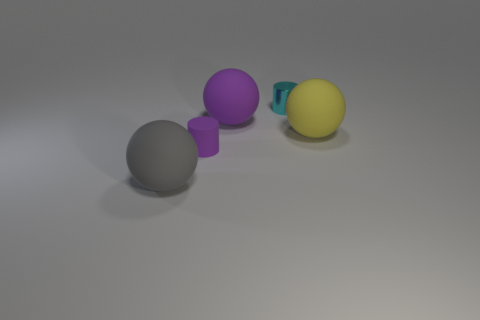The purple thing in front of the yellow matte object has what shape?
Provide a succinct answer. Cylinder. Are there fewer big gray objects than large blue metal cylinders?
Your response must be concise. No. There is a cylinder behind the yellow thing that is in front of the metal cylinder; are there any gray balls behind it?
Offer a very short reply. No. What number of matte things are objects or large balls?
Give a very brief answer. 4. There is a large yellow object; how many gray balls are behind it?
Your answer should be compact. 0. What number of big things are both on the right side of the tiny rubber cylinder and to the left of the tiny cyan cylinder?
Offer a very short reply. 1. What is the shape of the large yellow object that is made of the same material as the gray ball?
Your answer should be compact. Sphere. Do the cylinder on the right side of the tiny purple rubber cylinder and the cylinder that is on the left side of the tiny metal thing have the same size?
Your answer should be very brief. Yes. There is a big matte ball behind the large yellow matte sphere; what is its color?
Your response must be concise. Purple. What material is the cylinder behind the purple matte thing that is behind the small matte object made of?
Make the answer very short. Metal. 